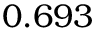<formula> <loc_0><loc_0><loc_500><loc_500>0 . 6 9 3</formula> 